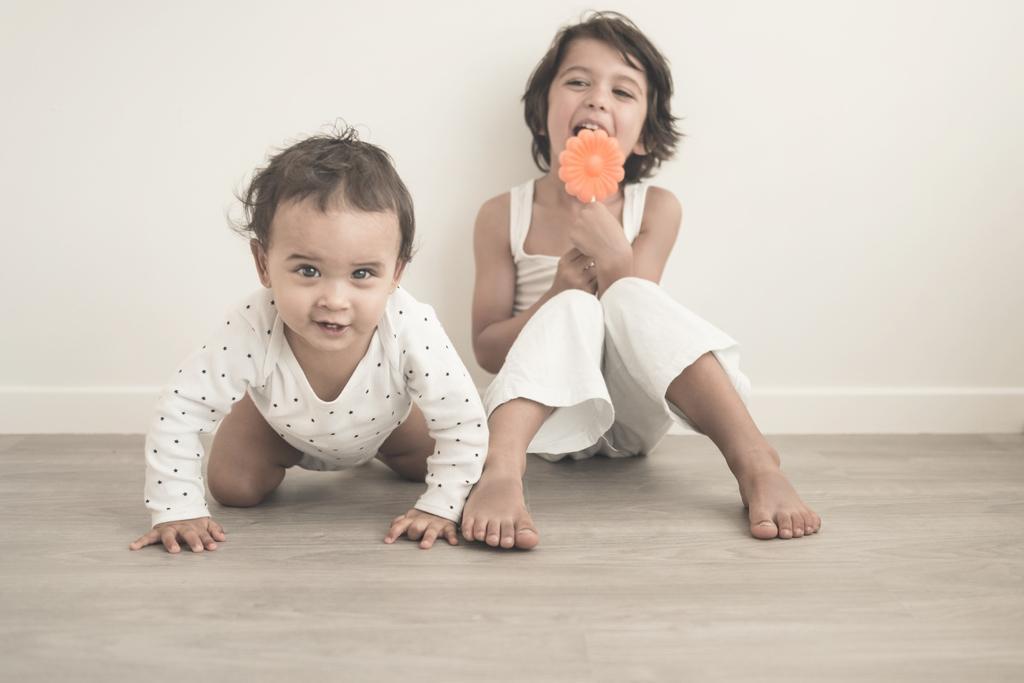Can you describe this image briefly? In this image, we can see kids and one of them is holding an object. In the background, there is a wall and at the bottom, there is floor. 